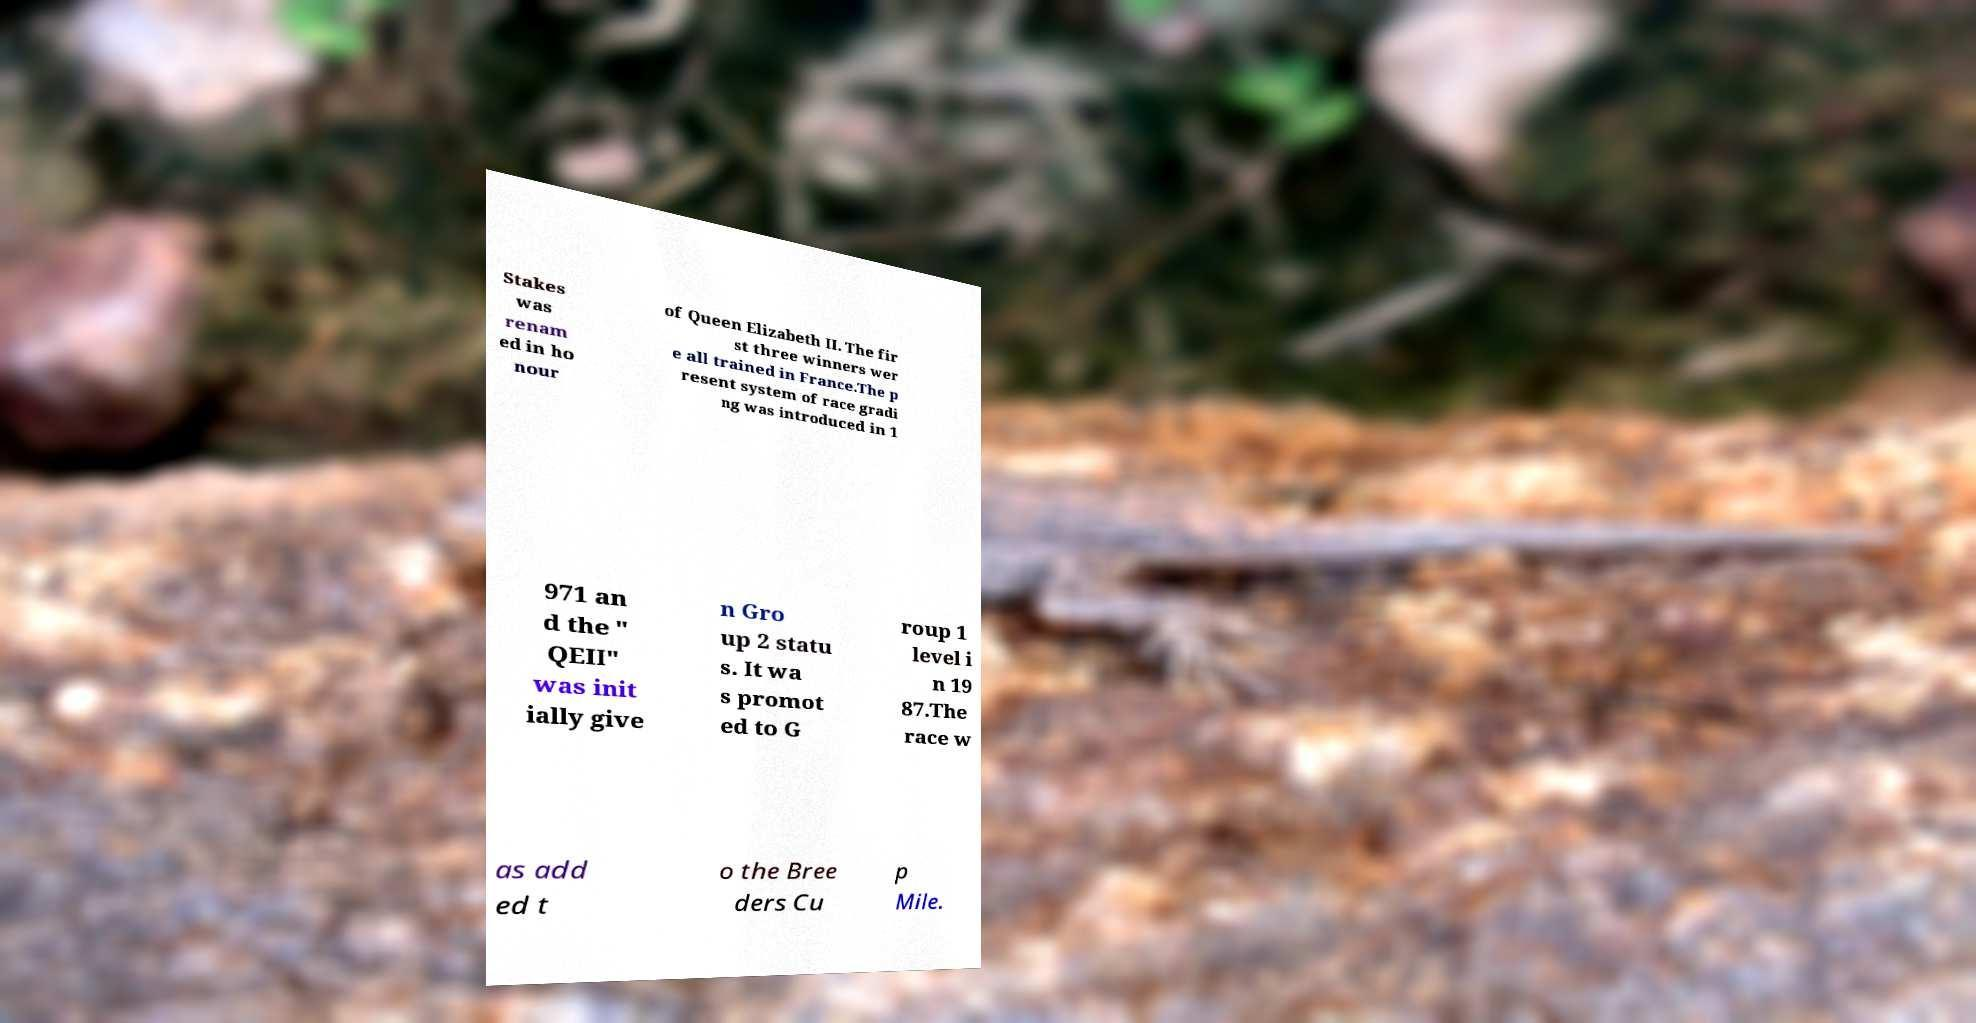Could you assist in decoding the text presented in this image and type it out clearly? Stakes was renam ed in ho nour of Queen Elizabeth II. The fir st three winners wer e all trained in France.The p resent system of race gradi ng was introduced in 1 971 an d the " QEII" was init ially give n Gro up 2 statu s. It wa s promot ed to G roup 1 level i n 19 87.The race w as add ed t o the Bree ders Cu p Mile. 